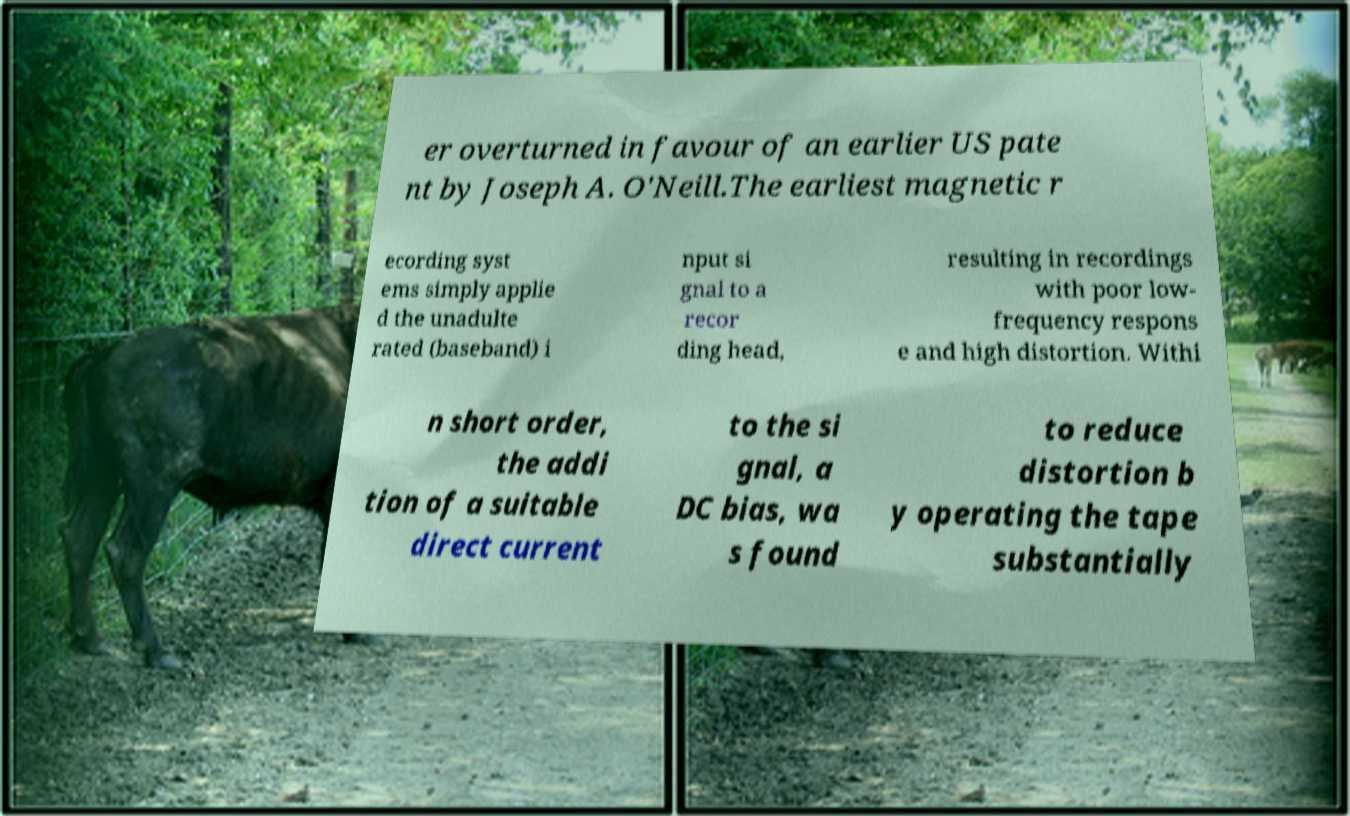Could you assist in decoding the text presented in this image and type it out clearly? er overturned in favour of an earlier US pate nt by Joseph A. O'Neill.The earliest magnetic r ecording syst ems simply applie d the unadulte rated (baseband) i nput si gnal to a recor ding head, resulting in recordings with poor low- frequency respons e and high distortion. Withi n short order, the addi tion of a suitable direct current to the si gnal, a DC bias, wa s found to reduce distortion b y operating the tape substantially 